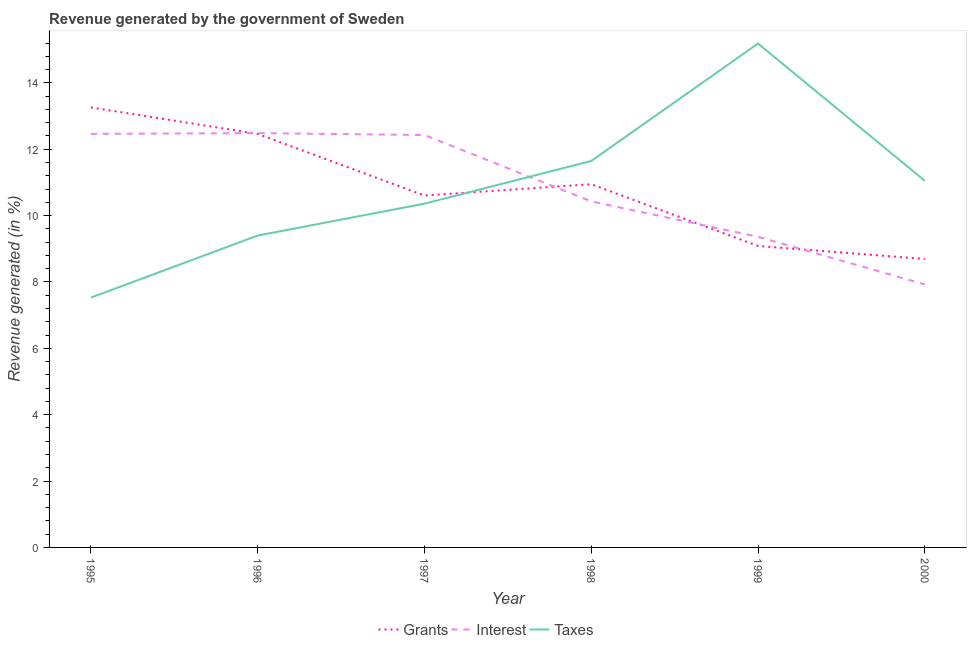Does the line corresponding to percentage of revenue generated by grants intersect with the line corresponding to percentage of revenue generated by taxes?
Keep it short and to the point. Yes. Is the number of lines equal to the number of legend labels?
Your answer should be compact. Yes. What is the percentage of revenue generated by grants in 1999?
Provide a short and direct response. 9.09. Across all years, what is the maximum percentage of revenue generated by taxes?
Offer a terse response. 15.19. Across all years, what is the minimum percentage of revenue generated by interest?
Your response must be concise. 7.93. In which year was the percentage of revenue generated by interest maximum?
Provide a succinct answer. 1996. In which year was the percentage of revenue generated by grants minimum?
Provide a short and direct response. 2000. What is the total percentage of revenue generated by interest in the graph?
Give a very brief answer. 65.1. What is the difference between the percentage of revenue generated by grants in 1995 and that in 1999?
Make the answer very short. 4.18. What is the difference between the percentage of revenue generated by taxes in 1997 and the percentage of revenue generated by interest in 1998?
Provide a short and direct response. -0.07. What is the average percentage of revenue generated by grants per year?
Your response must be concise. 10.84. In the year 1999, what is the difference between the percentage of revenue generated by interest and percentage of revenue generated by grants?
Provide a succinct answer. 0.28. In how many years, is the percentage of revenue generated by taxes greater than 6.8 %?
Keep it short and to the point. 6. What is the ratio of the percentage of revenue generated by taxes in 1996 to that in 2000?
Make the answer very short. 0.85. What is the difference between the highest and the second highest percentage of revenue generated by grants?
Make the answer very short. 0.8. What is the difference between the highest and the lowest percentage of revenue generated by interest?
Your response must be concise. 4.56. Is it the case that in every year, the sum of the percentage of revenue generated by grants and percentage of revenue generated by interest is greater than the percentage of revenue generated by taxes?
Provide a succinct answer. Yes. Does the percentage of revenue generated by grants monotonically increase over the years?
Give a very brief answer. No. Is the percentage of revenue generated by interest strictly greater than the percentage of revenue generated by grants over the years?
Your response must be concise. No. How many lines are there?
Make the answer very short. 3. How many years are there in the graph?
Offer a terse response. 6. What is the difference between two consecutive major ticks on the Y-axis?
Your answer should be very brief. 2. Does the graph contain any zero values?
Keep it short and to the point. No. How many legend labels are there?
Offer a terse response. 3. How are the legend labels stacked?
Ensure brevity in your answer.  Horizontal. What is the title of the graph?
Offer a very short reply. Revenue generated by the government of Sweden. Does "Services" appear as one of the legend labels in the graph?
Offer a very short reply. No. What is the label or title of the Y-axis?
Offer a terse response. Revenue generated (in %). What is the Revenue generated (in %) of Grants in 1995?
Your answer should be very brief. 13.26. What is the Revenue generated (in %) in Interest in 1995?
Offer a terse response. 12.46. What is the Revenue generated (in %) of Taxes in 1995?
Offer a terse response. 7.53. What is the Revenue generated (in %) in Grants in 1996?
Your response must be concise. 12.46. What is the Revenue generated (in %) of Interest in 1996?
Your answer should be very brief. 12.49. What is the Revenue generated (in %) of Taxes in 1996?
Keep it short and to the point. 9.4. What is the Revenue generated (in %) of Grants in 1997?
Offer a very short reply. 10.61. What is the Revenue generated (in %) of Interest in 1997?
Provide a short and direct response. 12.43. What is the Revenue generated (in %) in Taxes in 1997?
Make the answer very short. 10.36. What is the Revenue generated (in %) in Grants in 1998?
Provide a succinct answer. 10.95. What is the Revenue generated (in %) in Interest in 1998?
Provide a short and direct response. 10.43. What is the Revenue generated (in %) in Taxes in 1998?
Offer a very short reply. 11.65. What is the Revenue generated (in %) in Grants in 1999?
Your response must be concise. 9.09. What is the Revenue generated (in %) of Interest in 1999?
Your response must be concise. 9.36. What is the Revenue generated (in %) of Taxes in 1999?
Provide a short and direct response. 15.19. What is the Revenue generated (in %) in Grants in 2000?
Your response must be concise. 8.69. What is the Revenue generated (in %) in Interest in 2000?
Provide a short and direct response. 7.93. What is the Revenue generated (in %) of Taxes in 2000?
Offer a very short reply. 11.05. Across all years, what is the maximum Revenue generated (in %) in Grants?
Provide a short and direct response. 13.26. Across all years, what is the maximum Revenue generated (in %) of Interest?
Make the answer very short. 12.49. Across all years, what is the maximum Revenue generated (in %) in Taxes?
Ensure brevity in your answer.  15.19. Across all years, what is the minimum Revenue generated (in %) of Grants?
Offer a terse response. 8.69. Across all years, what is the minimum Revenue generated (in %) of Interest?
Your answer should be compact. 7.93. Across all years, what is the minimum Revenue generated (in %) of Taxes?
Keep it short and to the point. 7.53. What is the total Revenue generated (in %) of Grants in the graph?
Give a very brief answer. 65.06. What is the total Revenue generated (in %) of Interest in the graph?
Your answer should be very brief. 65.1. What is the total Revenue generated (in %) of Taxes in the graph?
Your answer should be compact. 65.17. What is the difference between the Revenue generated (in %) of Grants in 1995 and that in 1996?
Keep it short and to the point. 0.8. What is the difference between the Revenue generated (in %) of Interest in 1995 and that in 1996?
Your response must be concise. -0.02. What is the difference between the Revenue generated (in %) of Taxes in 1995 and that in 1996?
Ensure brevity in your answer.  -1.87. What is the difference between the Revenue generated (in %) of Grants in 1995 and that in 1997?
Make the answer very short. 2.66. What is the difference between the Revenue generated (in %) of Interest in 1995 and that in 1997?
Provide a short and direct response. 0.04. What is the difference between the Revenue generated (in %) of Taxes in 1995 and that in 1997?
Offer a very short reply. -2.83. What is the difference between the Revenue generated (in %) of Grants in 1995 and that in 1998?
Your answer should be very brief. 2.32. What is the difference between the Revenue generated (in %) of Interest in 1995 and that in 1998?
Provide a succinct answer. 2.04. What is the difference between the Revenue generated (in %) in Taxes in 1995 and that in 1998?
Keep it short and to the point. -4.12. What is the difference between the Revenue generated (in %) of Grants in 1995 and that in 1999?
Provide a short and direct response. 4.18. What is the difference between the Revenue generated (in %) in Interest in 1995 and that in 1999?
Make the answer very short. 3.1. What is the difference between the Revenue generated (in %) in Taxes in 1995 and that in 1999?
Offer a very short reply. -7.66. What is the difference between the Revenue generated (in %) of Grants in 1995 and that in 2000?
Your answer should be compact. 4.57. What is the difference between the Revenue generated (in %) of Interest in 1995 and that in 2000?
Make the answer very short. 4.54. What is the difference between the Revenue generated (in %) of Taxes in 1995 and that in 2000?
Provide a succinct answer. -3.52. What is the difference between the Revenue generated (in %) in Grants in 1996 and that in 1997?
Offer a very short reply. 1.86. What is the difference between the Revenue generated (in %) in Interest in 1996 and that in 1997?
Your response must be concise. 0.06. What is the difference between the Revenue generated (in %) in Taxes in 1996 and that in 1997?
Your answer should be compact. -0.96. What is the difference between the Revenue generated (in %) in Grants in 1996 and that in 1998?
Keep it short and to the point. 1.52. What is the difference between the Revenue generated (in %) of Interest in 1996 and that in 1998?
Keep it short and to the point. 2.06. What is the difference between the Revenue generated (in %) in Taxes in 1996 and that in 1998?
Your response must be concise. -2.25. What is the difference between the Revenue generated (in %) in Grants in 1996 and that in 1999?
Keep it short and to the point. 3.38. What is the difference between the Revenue generated (in %) in Interest in 1996 and that in 1999?
Make the answer very short. 3.12. What is the difference between the Revenue generated (in %) of Taxes in 1996 and that in 1999?
Offer a very short reply. -5.79. What is the difference between the Revenue generated (in %) of Grants in 1996 and that in 2000?
Make the answer very short. 3.77. What is the difference between the Revenue generated (in %) in Interest in 1996 and that in 2000?
Make the answer very short. 4.56. What is the difference between the Revenue generated (in %) in Taxes in 1996 and that in 2000?
Give a very brief answer. -1.65. What is the difference between the Revenue generated (in %) in Grants in 1997 and that in 1998?
Make the answer very short. -0.34. What is the difference between the Revenue generated (in %) of Interest in 1997 and that in 1998?
Offer a terse response. 2. What is the difference between the Revenue generated (in %) of Taxes in 1997 and that in 1998?
Your answer should be very brief. -1.29. What is the difference between the Revenue generated (in %) in Grants in 1997 and that in 1999?
Offer a very short reply. 1.52. What is the difference between the Revenue generated (in %) in Interest in 1997 and that in 1999?
Your response must be concise. 3.07. What is the difference between the Revenue generated (in %) of Taxes in 1997 and that in 1999?
Provide a short and direct response. -4.83. What is the difference between the Revenue generated (in %) of Grants in 1997 and that in 2000?
Provide a short and direct response. 1.91. What is the difference between the Revenue generated (in %) in Interest in 1997 and that in 2000?
Your response must be concise. 4.5. What is the difference between the Revenue generated (in %) of Taxes in 1997 and that in 2000?
Provide a succinct answer. -0.69. What is the difference between the Revenue generated (in %) of Grants in 1998 and that in 1999?
Your answer should be compact. 1.86. What is the difference between the Revenue generated (in %) of Interest in 1998 and that in 1999?
Offer a terse response. 1.07. What is the difference between the Revenue generated (in %) of Taxes in 1998 and that in 1999?
Provide a short and direct response. -3.54. What is the difference between the Revenue generated (in %) of Grants in 1998 and that in 2000?
Keep it short and to the point. 2.25. What is the difference between the Revenue generated (in %) in Interest in 1998 and that in 2000?
Offer a terse response. 2.5. What is the difference between the Revenue generated (in %) in Taxes in 1998 and that in 2000?
Provide a succinct answer. 0.6. What is the difference between the Revenue generated (in %) in Grants in 1999 and that in 2000?
Give a very brief answer. 0.39. What is the difference between the Revenue generated (in %) in Interest in 1999 and that in 2000?
Provide a short and direct response. 1.44. What is the difference between the Revenue generated (in %) of Taxes in 1999 and that in 2000?
Keep it short and to the point. 4.14. What is the difference between the Revenue generated (in %) in Grants in 1995 and the Revenue generated (in %) in Interest in 1996?
Offer a terse response. 0.78. What is the difference between the Revenue generated (in %) of Grants in 1995 and the Revenue generated (in %) of Taxes in 1996?
Your response must be concise. 3.86. What is the difference between the Revenue generated (in %) of Interest in 1995 and the Revenue generated (in %) of Taxes in 1996?
Give a very brief answer. 3.06. What is the difference between the Revenue generated (in %) in Grants in 1995 and the Revenue generated (in %) in Interest in 1997?
Keep it short and to the point. 0.83. What is the difference between the Revenue generated (in %) in Grants in 1995 and the Revenue generated (in %) in Taxes in 1997?
Your response must be concise. 2.9. What is the difference between the Revenue generated (in %) in Interest in 1995 and the Revenue generated (in %) in Taxes in 1997?
Your answer should be very brief. 2.1. What is the difference between the Revenue generated (in %) in Grants in 1995 and the Revenue generated (in %) in Interest in 1998?
Your answer should be compact. 2.83. What is the difference between the Revenue generated (in %) of Grants in 1995 and the Revenue generated (in %) of Taxes in 1998?
Make the answer very short. 1.61. What is the difference between the Revenue generated (in %) of Interest in 1995 and the Revenue generated (in %) of Taxes in 1998?
Give a very brief answer. 0.82. What is the difference between the Revenue generated (in %) in Grants in 1995 and the Revenue generated (in %) in Interest in 1999?
Your response must be concise. 3.9. What is the difference between the Revenue generated (in %) of Grants in 1995 and the Revenue generated (in %) of Taxes in 1999?
Provide a succinct answer. -1.92. What is the difference between the Revenue generated (in %) of Interest in 1995 and the Revenue generated (in %) of Taxes in 1999?
Make the answer very short. -2.72. What is the difference between the Revenue generated (in %) of Grants in 1995 and the Revenue generated (in %) of Interest in 2000?
Provide a succinct answer. 5.34. What is the difference between the Revenue generated (in %) in Grants in 1995 and the Revenue generated (in %) in Taxes in 2000?
Give a very brief answer. 2.21. What is the difference between the Revenue generated (in %) of Interest in 1995 and the Revenue generated (in %) of Taxes in 2000?
Provide a succinct answer. 1.41. What is the difference between the Revenue generated (in %) of Grants in 1996 and the Revenue generated (in %) of Interest in 1997?
Keep it short and to the point. 0.03. What is the difference between the Revenue generated (in %) in Grants in 1996 and the Revenue generated (in %) in Taxes in 1997?
Provide a succinct answer. 2.1. What is the difference between the Revenue generated (in %) of Interest in 1996 and the Revenue generated (in %) of Taxes in 1997?
Keep it short and to the point. 2.13. What is the difference between the Revenue generated (in %) of Grants in 1996 and the Revenue generated (in %) of Interest in 1998?
Provide a short and direct response. 2.04. What is the difference between the Revenue generated (in %) of Grants in 1996 and the Revenue generated (in %) of Taxes in 1998?
Give a very brief answer. 0.82. What is the difference between the Revenue generated (in %) of Interest in 1996 and the Revenue generated (in %) of Taxes in 1998?
Make the answer very short. 0.84. What is the difference between the Revenue generated (in %) of Grants in 1996 and the Revenue generated (in %) of Interest in 1999?
Keep it short and to the point. 3.1. What is the difference between the Revenue generated (in %) in Grants in 1996 and the Revenue generated (in %) in Taxes in 1999?
Make the answer very short. -2.72. What is the difference between the Revenue generated (in %) in Interest in 1996 and the Revenue generated (in %) in Taxes in 1999?
Offer a terse response. -2.7. What is the difference between the Revenue generated (in %) in Grants in 1996 and the Revenue generated (in %) in Interest in 2000?
Offer a terse response. 4.54. What is the difference between the Revenue generated (in %) in Grants in 1996 and the Revenue generated (in %) in Taxes in 2000?
Offer a terse response. 1.41. What is the difference between the Revenue generated (in %) in Interest in 1996 and the Revenue generated (in %) in Taxes in 2000?
Your answer should be compact. 1.44. What is the difference between the Revenue generated (in %) of Grants in 1997 and the Revenue generated (in %) of Interest in 1998?
Keep it short and to the point. 0.18. What is the difference between the Revenue generated (in %) in Grants in 1997 and the Revenue generated (in %) in Taxes in 1998?
Provide a succinct answer. -1.04. What is the difference between the Revenue generated (in %) of Interest in 1997 and the Revenue generated (in %) of Taxes in 1998?
Keep it short and to the point. 0.78. What is the difference between the Revenue generated (in %) of Grants in 1997 and the Revenue generated (in %) of Interest in 1999?
Offer a very short reply. 1.24. What is the difference between the Revenue generated (in %) in Grants in 1997 and the Revenue generated (in %) in Taxes in 1999?
Keep it short and to the point. -4.58. What is the difference between the Revenue generated (in %) in Interest in 1997 and the Revenue generated (in %) in Taxes in 1999?
Offer a very short reply. -2.76. What is the difference between the Revenue generated (in %) in Grants in 1997 and the Revenue generated (in %) in Interest in 2000?
Provide a short and direct response. 2.68. What is the difference between the Revenue generated (in %) in Grants in 1997 and the Revenue generated (in %) in Taxes in 2000?
Give a very brief answer. -0.44. What is the difference between the Revenue generated (in %) in Interest in 1997 and the Revenue generated (in %) in Taxes in 2000?
Provide a succinct answer. 1.38. What is the difference between the Revenue generated (in %) in Grants in 1998 and the Revenue generated (in %) in Interest in 1999?
Make the answer very short. 1.58. What is the difference between the Revenue generated (in %) of Grants in 1998 and the Revenue generated (in %) of Taxes in 1999?
Provide a succinct answer. -4.24. What is the difference between the Revenue generated (in %) in Interest in 1998 and the Revenue generated (in %) in Taxes in 1999?
Your response must be concise. -4.76. What is the difference between the Revenue generated (in %) in Grants in 1998 and the Revenue generated (in %) in Interest in 2000?
Your answer should be compact. 3.02. What is the difference between the Revenue generated (in %) in Grants in 1998 and the Revenue generated (in %) in Taxes in 2000?
Provide a succinct answer. -0.1. What is the difference between the Revenue generated (in %) of Interest in 1998 and the Revenue generated (in %) of Taxes in 2000?
Offer a very short reply. -0.62. What is the difference between the Revenue generated (in %) of Grants in 1999 and the Revenue generated (in %) of Interest in 2000?
Your response must be concise. 1.16. What is the difference between the Revenue generated (in %) in Grants in 1999 and the Revenue generated (in %) in Taxes in 2000?
Keep it short and to the point. -1.96. What is the difference between the Revenue generated (in %) in Interest in 1999 and the Revenue generated (in %) in Taxes in 2000?
Provide a succinct answer. -1.69. What is the average Revenue generated (in %) of Grants per year?
Offer a terse response. 10.84. What is the average Revenue generated (in %) of Interest per year?
Offer a very short reply. 10.85. What is the average Revenue generated (in %) of Taxes per year?
Provide a succinct answer. 10.86. In the year 1995, what is the difference between the Revenue generated (in %) in Grants and Revenue generated (in %) in Interest?
Give a very brief answer. 0.8. In the year 1995, what is the difference between the Revenue generated (in %) in Grants and Revenue generated (in %) in Taxes?
Give a very brief answer. 5.73. In the year 1995, what is the difference between the Revenue generated (in %) in Interest and Revenue generated (in %) in Taxes?
Offer a terse response. 4.94. In the year 1996, what is the difference between the Revenue generated (in %) of Grants and Revenue generated (in %) of Interest?
Your answer should be compact. -0.02. In the year 1996, what is the difference between the Revenue generated (in %) of Grants and Revenue generated (in %) of Taxes?
Give a very brief answer. 3.06. In the year 1996, what is the difference between the Revenue generated (in %) of Interest and Revenue generated (in %) of Taxes?
Your answer should be compact. 3.09. In the year 1997, what is the difference between the Revenue generated (in %) in Grants and Revenue generated (in %) in Interest?
Offer a very short reply. -1.82. In the year 1997, what is the difference between the Revenue generated (in %) in Grants and Revenue generated (in %) in Taxes?
Keep it short and to the point. 0.25. In the year 1997, what is the difference between the Revenue generated (in %) of Interest and Revenue generated (in %) of Taxes?
Provide a succinct answer. 2.07. In the year 1998, what is the difference between the Revenue generated (in %) of Grants and Revenue generated (in %) of Interest?
Offer a terse response. 0.52. In the year 1998, what is the difference between the Revenue generated (in %) in Grants and Revenue generated (in %) in Taxes?
Offer a very short reply. -0.7. In the year 1998, what is the difference between the Revenue generated (in %) of Interest and Revenue generated (in %) of Taxes?
Your response must be concise. -1.22. In the year 1999, what is the difference between the Revenue generated (in %) of Grants and Revenue generated (in %) of Interest?
Your response must be concise. -0.28. In the year 1999, what is the difference between the Revenue generated (in %) in Grants and Revenue generated (in %) in Taxes?
Provide a succinct answer. -6.1. In the year 1999, what is the difference between the Revenue generated (in %) in Interest and Revenue generated (in %) in Taxes?
Provide a succinct answer. -5.82. In the year 2000, what is the difference between the Revenue generated (in %) in Grants and Revenue generated (in %) in Interest?
Offer a terse response. 0.77. In the year 2000, what is the difference between the Revenue generated (in %) of Grants and Revenue generated (in %) of Taxes?
Provide a short and direct response. -2.36. In the year 2000, what is the difference between the Revenue generated (in %) in Interest and Revenue generated (in %) in Taxes?
Ensure brevity in your answer.  -3.12. What is the ratio of the Revenue generated (in %) in Grants in 1995 to that in 1996?
Your answer should be compact. 1.06. What is the ratio of the Revenue generated (in %) of Taxes in 1995 to that in 1996?
Keep it short and to the point. 0.8. What is the ratio of the Revenue generated (in %) in Grants in 1995 to that in 1997?
Offer a terse response. 1.25. What is the ratio of the Revenue generated (in %) of Taxes in 1995 to that in 1997?
Your response must be concise. 0.73. What is the ratio of the Revenue generated (in %) in Grants in 1995 to that in 1998?
Your answer should be very brief. 1.21. What is the ratio of the Revenue generated (in %) of Interest in 1995 to that in 1998?
Give a very brief answer. 1.2. What is the ratio of the Revenue generated (in %) in Taxes in 1995 to that in 1998?
Make the answer very short. 0.65. What is the ratio of the Revenue generated (in %) in Grants in 1995 to that in 1999?
Make the answer very short. 1.46. What is the ratio of the Revenue generated (in %) of Interest in 1995 to that in 1999?
Provide a succinct answer. 1.33. What is the ratio of the Revenue generated (in %) in Taxes in 1995 to that in 1999?
Offer a terse response. 0.5. What is the ratio of the Revenue generated (in %) in Grants in 1995 to that in 2000?
Give a very brief answer. 1.53. What is the ratio of the Revenue generated (in %) in Interest in 1995 to that in 2000?
Offer a terse response. 1.57. What is the ratio of the Revenue generated (in %) of Taxes in 1995 to that in 2000?
Your answer should be very brief. 0.68. What is the ratio of the Revenue generated (in %) of Grants in 1996 to that in 1997?
Offer a very short reply. 1.18. What is the ratio of the Revenue generated (in %) in Taxes in 1996 to that in 1997?
Your response must be concise. 0.91. What is the ratio of the Revenue generated (in %) in Grants in 1996 to that in 1998?
Your response must be concise. 1.14. What is the ratio of the Revenue generated (in %) of Interest in 1996 to that in 1998?
Ensure brevity in your answer.  1.2. What is the ratio of the Revenue generated (in %) of Taxes in 1996 to that in 1998?
Your answer should be very brief. 0.81. What is the ratio of the Revenue generated (in %) of Grants in 1996 to that in 1999?
Your response must be concise. 1.37. What is the ratio of the Revenue generated (in %) of Interest in 1996 to that in 1999?
Give a very brief answer. 1.33. What is the ratio of the Revenue generated (in %) in Taxes in 1996 to that in 1999?
Your response must be concise. 0.62. What is the ratio of the Revenue generated (in %) of Grants in 1996 to that in 2000?
Provide a succinct answer. 1.43. What is the ratio of the Revenue generated (in %) in Interest in 1996 to that in 2000?
Provide a succinct answer. 1.58. What is the ratio of the Revenue generated (in %) in Taxes in 1996 to that in 2000?
Your answer should be very brief. 0.85. What is the ratio of the Revenue generated (in %) of Grants in 1997 to that in 1998?
Give a very brief answer. 0.97. What is the ratio of the Revenue generated (in %) in Interest in 1997 to that in 1998?
Give a very brief answer. 1.19. What is the ratio of the Revenue generated (in %) in Taxes in 1997 to that in 1998?
Your answer should be very brief. 0.89. What is the ratio of the Revenue generated (in %) in Grants in 1997 to that in 1999?
Keep it short and to the point. 1.17. What is the ratio of the Revenue generated (in %) in Interest in 1997 to that in 1999?
Your answer should be compact. 1.33. What is the ratio of the Revenue generated (in %) in Taxes in 1997 to that in 1999?
Your answer should be compact. 0.68. What is the ratio of the Revenue generated (in %) in Grants in 1997 to that in 2000?
Offer a very short reply. 1.22. What is the ratio of the Revenue generated (in %) in Interest in 1997 to that in 2000?
Make the answer very short. 1.57. What is the ratio of the Revenue generated (in %) in Taxes in 1997 to that in 2000?
Keep it short and to the point. 0.94. What is the ratio of the Revenue generated (in %) of Grants in 1998 to that in 1999?
Provide a succinct answer. 1.2. What is the ratio of the Revenue generated (in %) in Interest in 1998 to that in 1999?
Give a very brief answer. 1.11. What is the ratio of the Revenue generated (in %) of Taxes in 1998 to that in 1999?
Offer a terse response. 0.77. What is the ratio of the Revenue generated (in %) in Grants in 1998 to that in 2000?
Your answer should be very brief. 1.26. What is the ratio of the Revenue generated (in %) of Interest in 1998 to that in 2000?
Make the answer very short. 1.32. What is the ratio of the Revenue generated (in %) of Taxes in 1998 to that in 2000?
Your response must be concise. 1.05. What is the ratio of the Revenue generated (in %) of Grants in 1999 to that in 2000?
Your answer should be compact. 1.05. What is the ratio of the Revenue generated (in %) in Interest in 1999 to that in 2000?
Provide a succinct answer. 1.18. What is the ratio of the Revenue generated (in %) in Taxes in 1999 to that in 2000?
Give a very brief answer. 1.37. What is the difference between the highest and the second highest Revenue generated (in %) in Grants?
Provide a short and direct response. 0.8. What is the difference between the highest and the second highest Revenue generated (in %) in Interest?
Your answer should be compact. 0.02. What is the difference between the highest and the second highest Revenue generated (in %) of Taxes?
Keep it short and to the point. 3.54. What is the difference between the highest and the lowest Revenue generated (in %) of Grants?
Ensure brevity in your answer.  4.57. What is the difference between the highest and the lowest Revenue generated (in %) in Interest?
Provide a succinct answer. 4.56. What is the difference between the highest and the lowest Revenue generated (in %) of Taxes?
Provide a short and direct response. 7.66. 